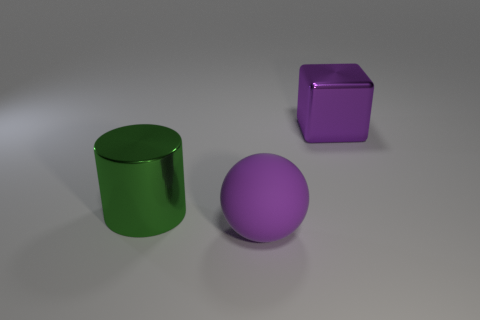The cylinder is what size?
Your answer should be compact. Large. What size is the thing behind the large green metal cylinder?
Offer a terse response. Large. There is a big thing that is both to the right of the big green metallic thing and left of the purple block; what shape is it?
Ensure brevity in your answer.  Sphere. How many other things are there of the same shape as the green shiny thing?
Provide a succinct answer. 0. There is a matte object that is the same size as the green metallic thing; what color is it?
Offer a terse response. Purple. How many objects are cyan rubber cylinders or rubber objects?
Keep it short and to the point. 1. Are there any large green things in front of the purple matte thing?
Give a very brief answer. No. Is there a sphere that has the same material as the purple block?
Ensure brevity in your answer.  No. How many cylinders are either tiny purple matte objects or large rubber things?
Provide a succinct answer. 0. Are there more large green metallic cylinders that are behind the large rubber ball than blocks that are behind the cube?
Provide a succinct answer. Yes. 